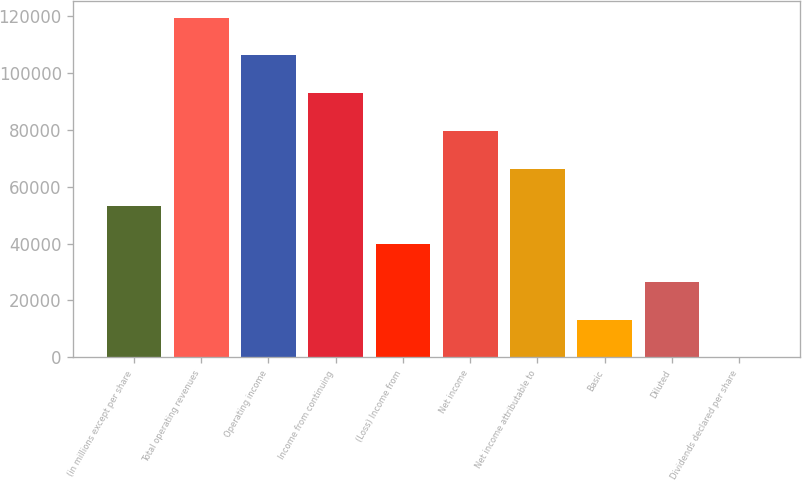Convert chart to OTSL. <chart><loc_0><loc_0><loc_500><loc_500><bar_chart><fcel>(in millions except per share<fcel>Total operating revenues<fcel>Operating income<fcel>Income from continuing<fcel>(Loss) Income from<fcel>Net income<fcel>Net income attributable to<fcel>Basic<fcel>Diluted<fcel>Dividends declared per share<nl><fcel>53106.4<fcel>119485<fcel>106209<fcel>92933.7<fcel>39830.6<fcel>79657.9<fcel>66382.2<fcel>13279.1<fcel>26554.9<fcel>3.36<nl></chart> 